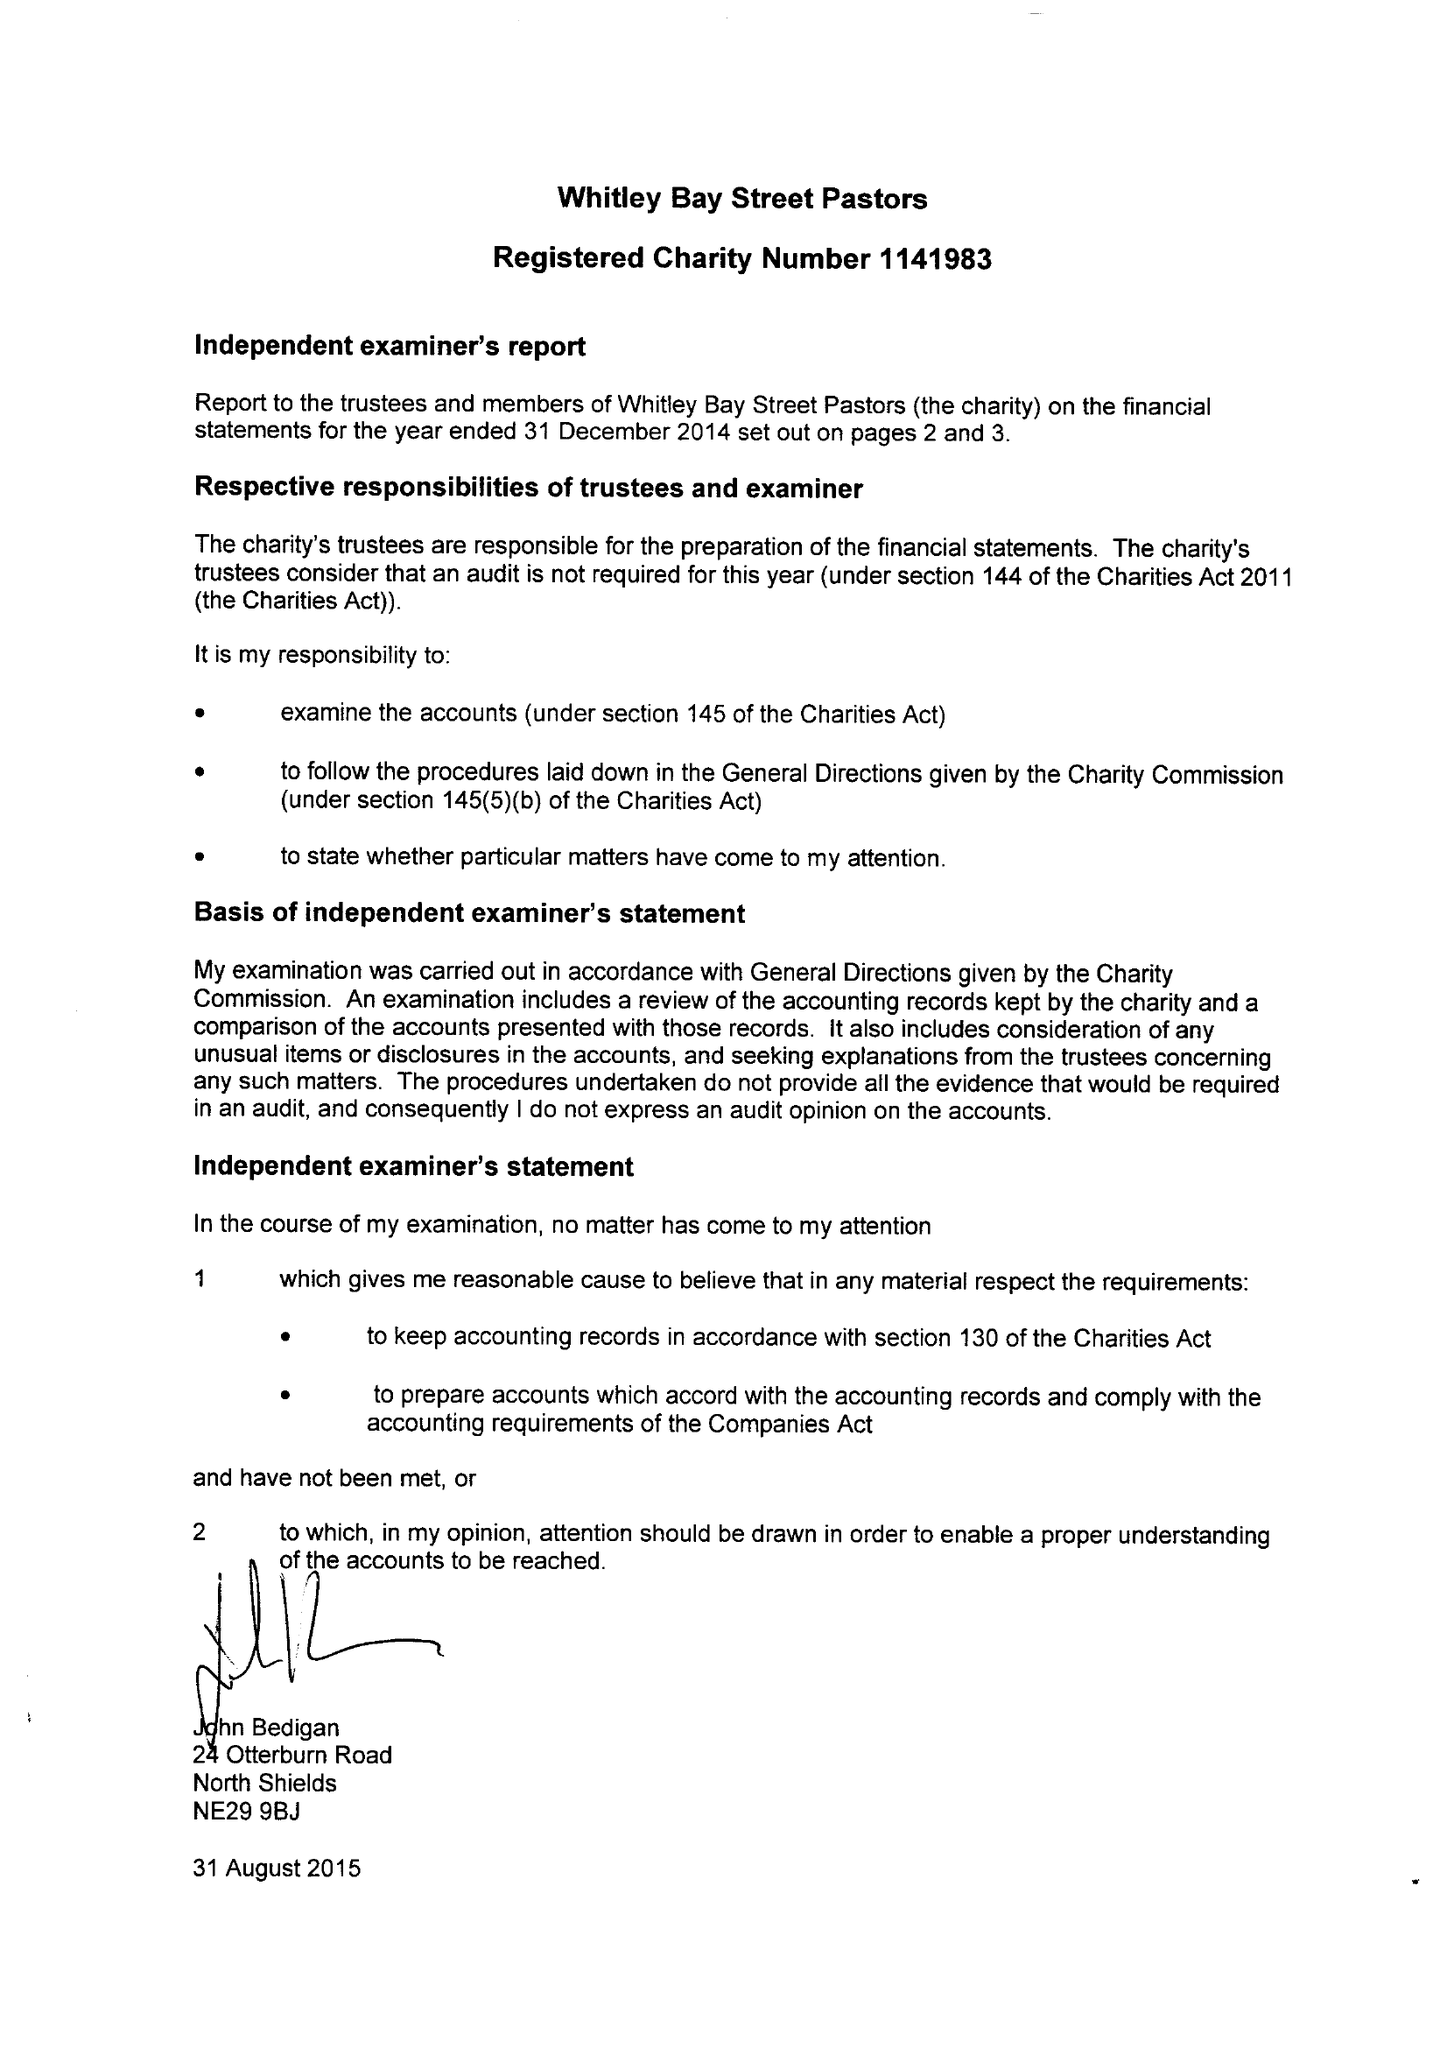What is the value for the spending_annually_in_british_pounds?
Answer the question using a single word or phrase. 30300.00 